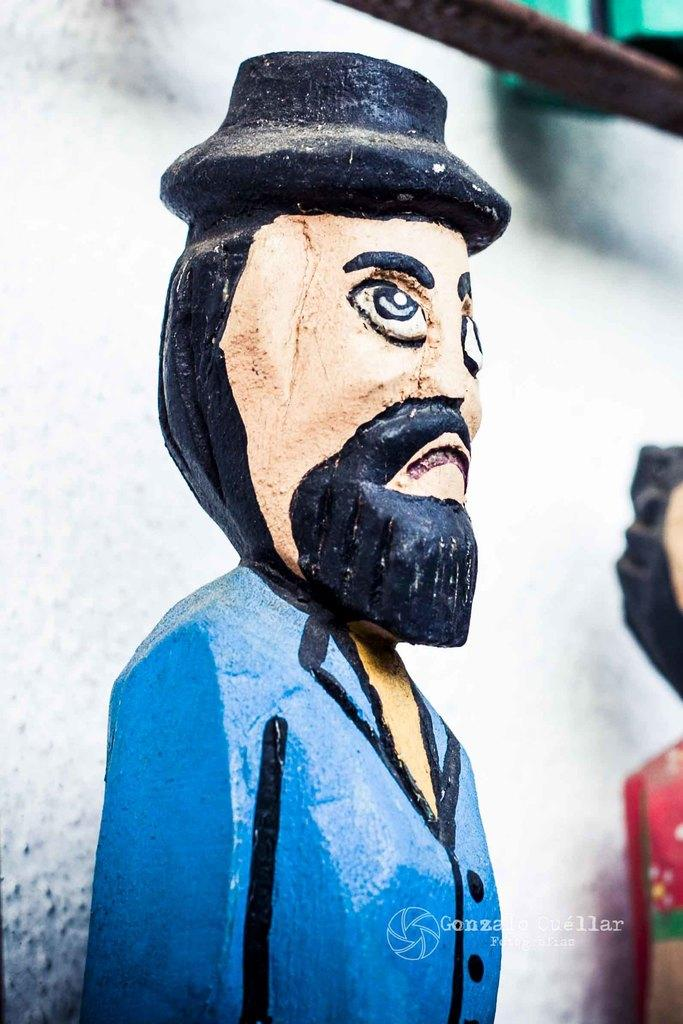What is the main subject of the image? There is a statue of a person in the image. Are there any other statues in the image? Yes, there is another statue on the right side of the image. What can be seen behind the statues? The background of the image is a white wall. What is the purpose of the iron bar at the top of the image? The iron bar at the top of the image could be for support or decoration. What type of lumber is being used to construct the sheet in the image? There is no lumber or sheet present in the image; it features two statues and a white wall background. 